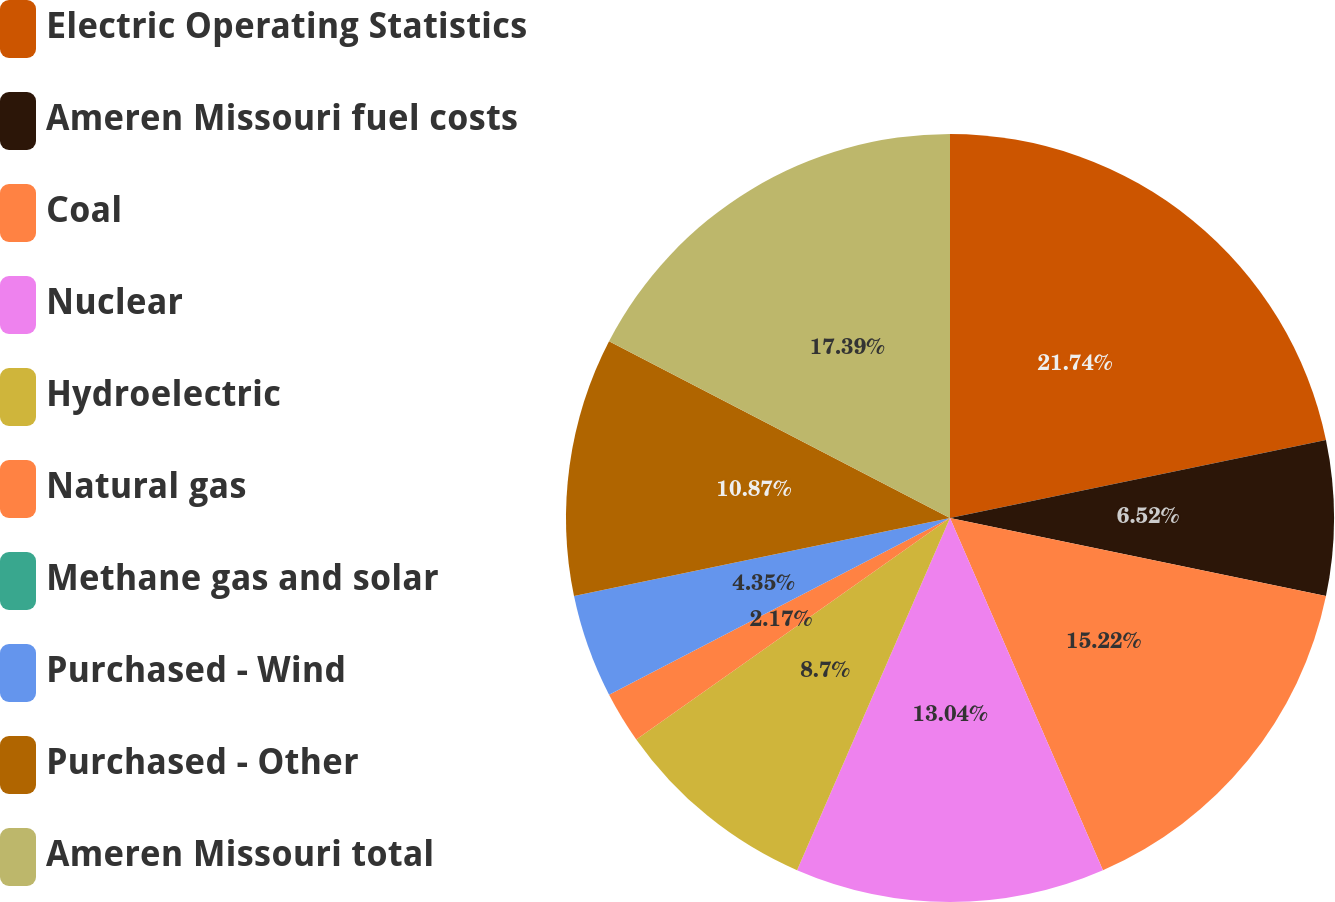<chart> <loc_0><loc_0><loc_500><loc_500><pie_chart><fcel>Electric Operating Statistics<fcel>Ameren Missouri fuel costs<fcel>Coal<fcel>Nuclear<fcel>Hydroelectric<fcel>Natural gas<fcel>Methane gas and solar<fcel>Purchased - Wind<fcel>Purchased - Other<fcel>Ameren Missouri total<nl><fcel>21.74%<fcel>6.52%<fcel>15.22%<fcel>13.04%<fcel>8.7%<fcel>2.17%<fcel>0.0%<fcel>4.35%<fcel>10.87%<fcel>17.39%<nl></chart> 